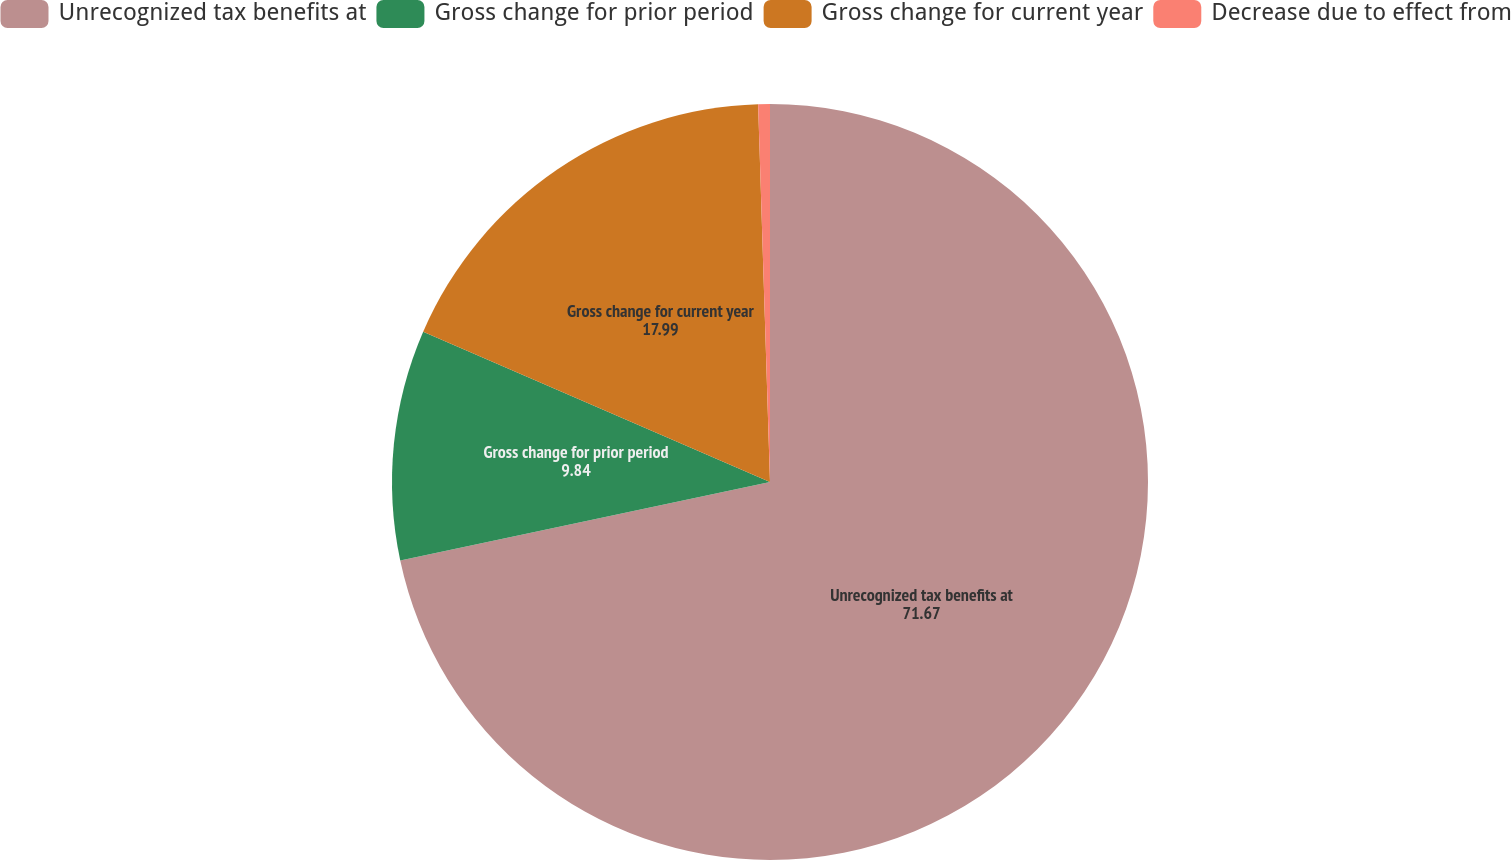<chart> <loc_0><loc_0><loc_500><loc_500><pie_chart><fcel>Unrecognized tax benefits at<fcel>Gross change for prior period<fcel>Gross change for current year<fcel>Decrease due to effect from<nl><fcel>71.67%<fcel>9.84%<fcel>17.99%<fcel>0.5%<nl></chart> 